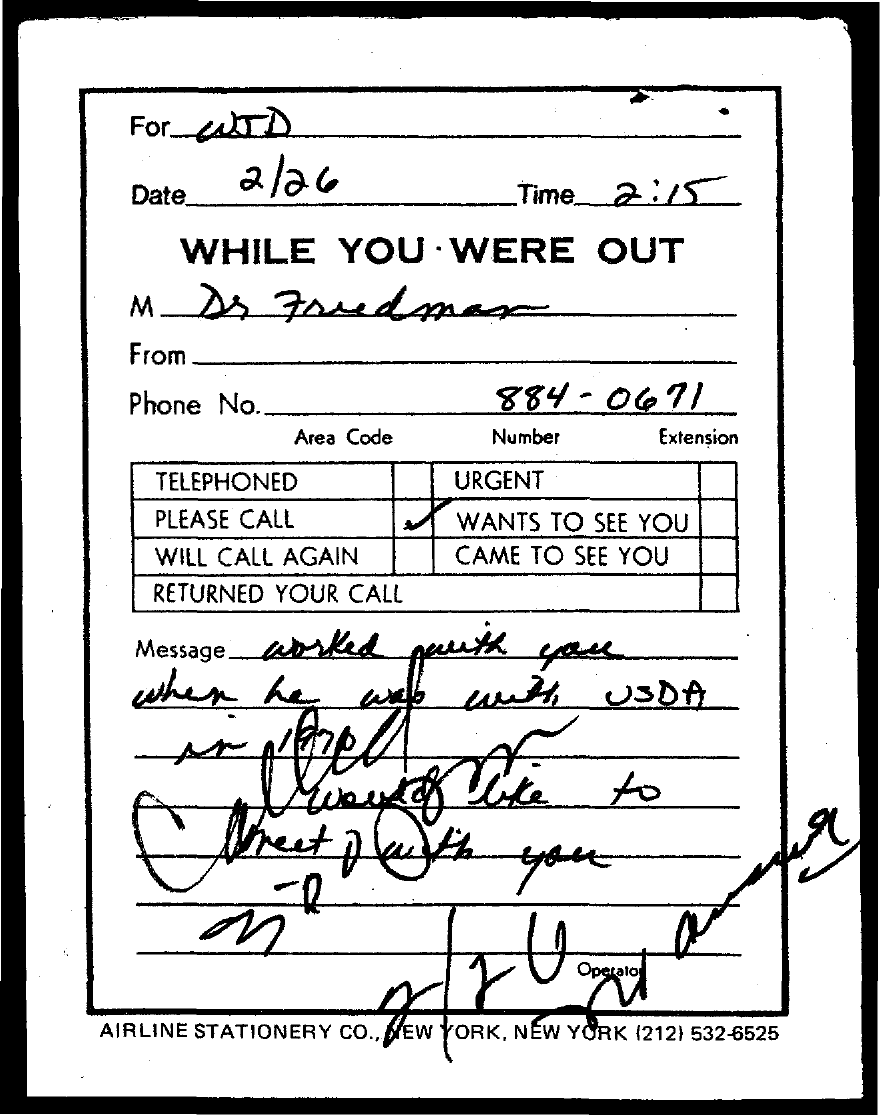What is the date mentioned in the document?
Offer a terse response. 2/26. What is the time mentioned in the document?
Keep it short and to the point. 2:15. 